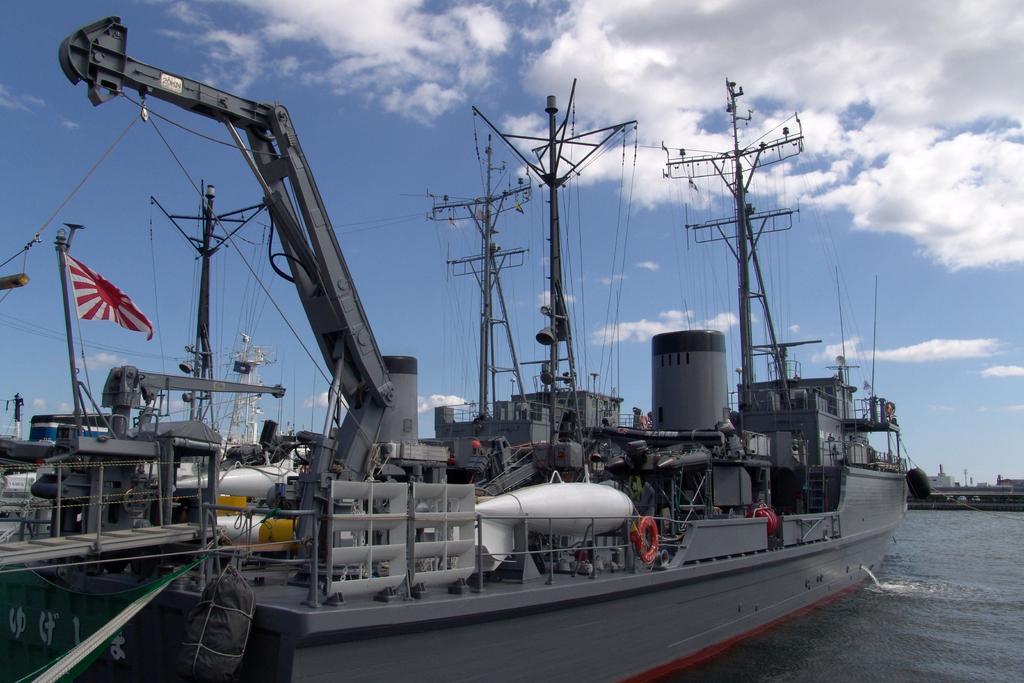Can you describe this image briefly? In this picture we can see the ships, poles, wires, flag. On the right side of the image we can see the water, buildings, poles. At the top of the image we can see the clouds in the sky. 